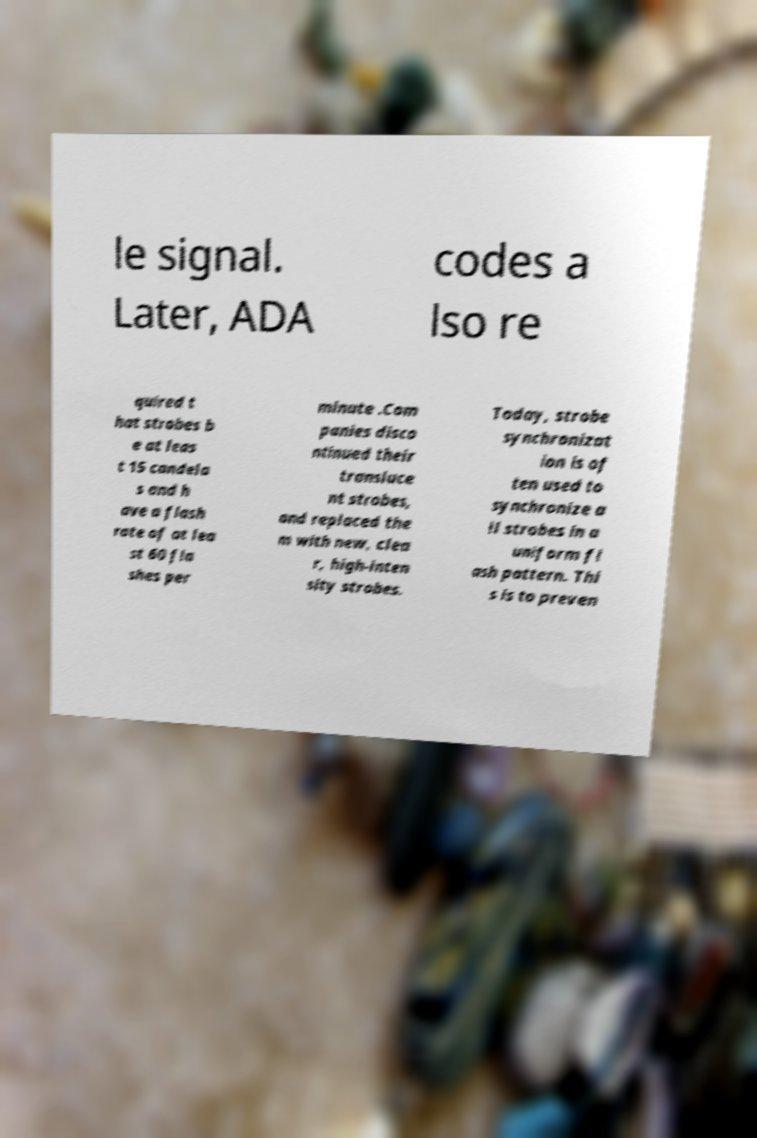There's text embedded in this image that I need extracted. Can you transcribe it verbatim? le signal. Later, ADA codes a lso re quired t hat strobes b e at leas t 15 candela s and h ave a flash rate of at lea st 60 fla shes per minute .Com panies disco ntinued their transluce nt strobes, and replaced the m with new, clea r, high-inten sity strobes. Today, strobe synchronizat ion is of ten used to synchronize a ll strobes in a uniform fl ash pattern. Thi s is to preven 